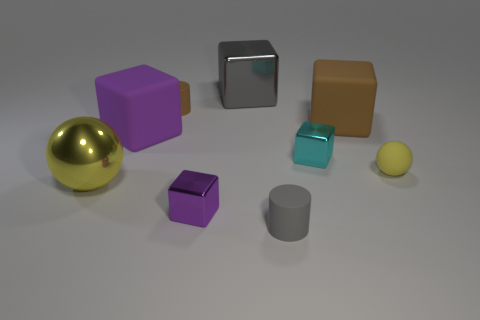What number of spheres are tiny brown rubber things or small red objects?
Offer a very short reply. 0. What material is the other thing that is the same shape as the tiny brown rubber thing?
Make the answer very short. Rubber. There is a yellow object that is the same material as the cyan cube; what is its size?
Ensure brevity in your answer.  Large. Is the shape of the gray object in front of the small yellow thing the same as the brown object that is in front of the tiny brown cylinder?
Provide a succinct answer. No. What is the color of the small cylinder that is the same material as the small brown thing?
Keep it short and to the point. Gray. There is a metal block that is right of the tiny gray rubber cylinder; does it have the same size as the brown rubber thing that is on the left side of the tiny gray cylinder?
Your answer should be compact. Yes. What shape is the matte object that is behind the yellow rubber ball and on the right side of the big gray object?
Keep it short and to the point. Cube. Are there any objects made of the same material as the big gray cube?
Your answer should be very brief. Yes. What material is the cylinder that is the same color as the big metal cube?
Your answer should be compact. Rubber. Do the yellow ball that is left of the tiny yellow rubber thing and the yellow sphere that is to the right of the large gray cube have the same material?
Your response must be concise. No. 